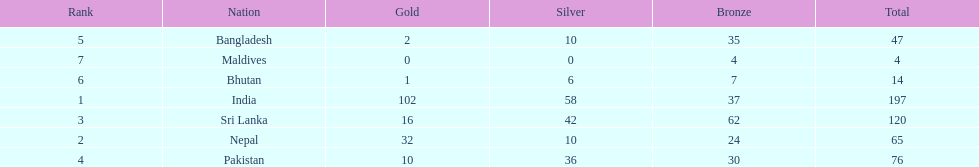What is the difference between the nation with the most medals and the nation with the least amount of medals? 193. 